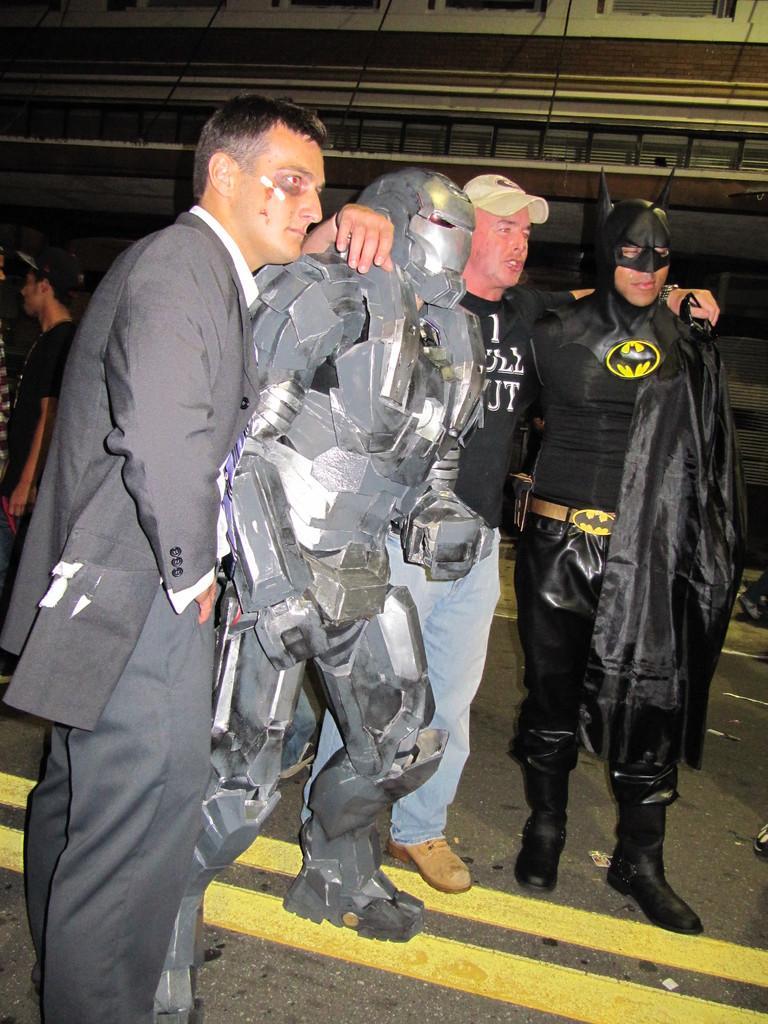Could you give a brief overview of what you see in this image? In this image there are two persons posing with a man dressed in Batman and Iron man are posing for the camera. 